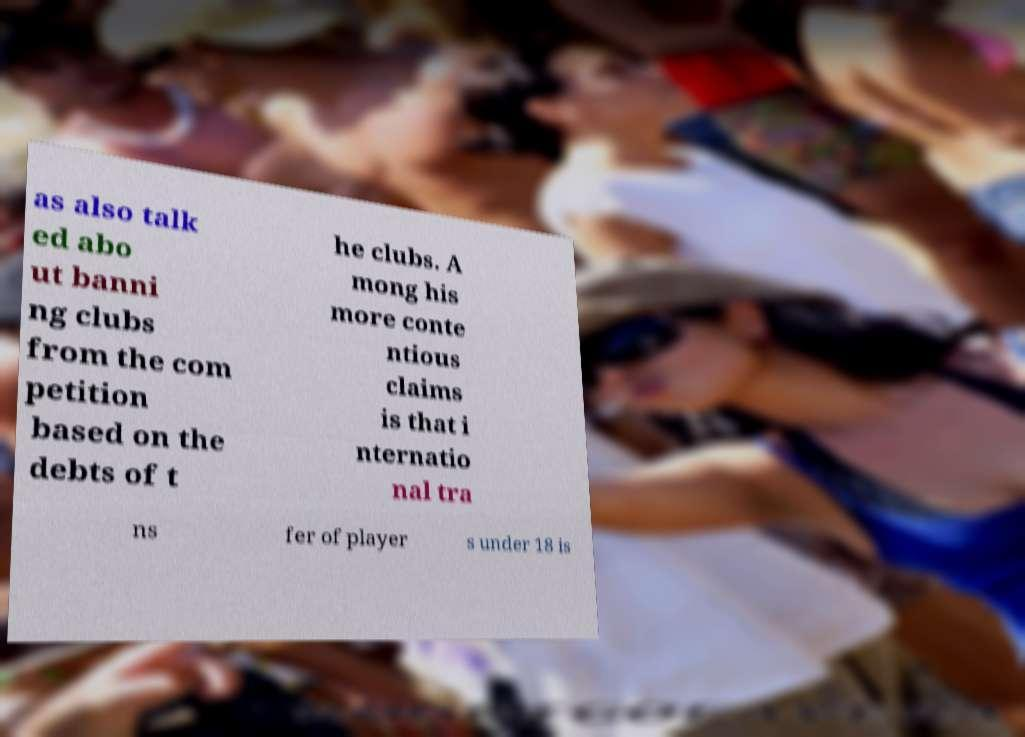What messages or text are displayed in this image? I need them in a readable, typed format. as also talk ed abo ut banni ng clubs from the com petition based on the debts of t he clubs. A mong his more conte ntious claims is that i nternatio nal tra ns fer of player s under 18 is 